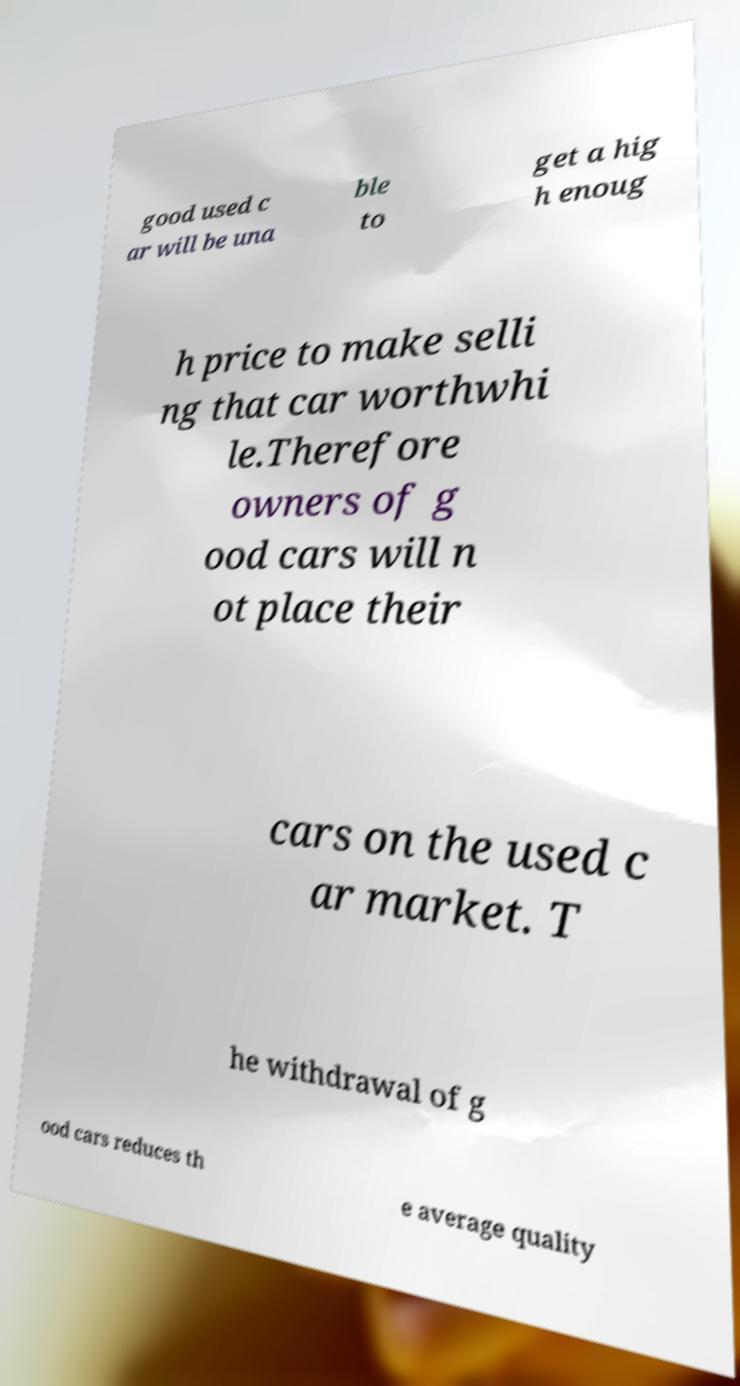Please read and relay the text visible in this image. What does it say? good used c ar will be una ble to get a hig h enoug h price to make selli ng that car worthwhi le.Therefore owners of g ood cars will n ot place their cars on the used c ar market. T he withdrawal of g ood cars reduces th e average quality 